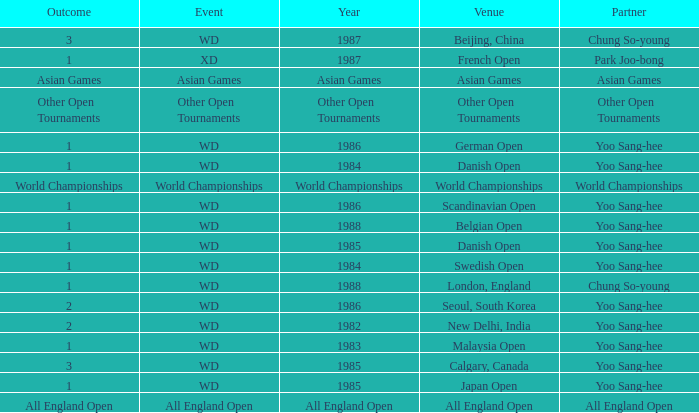What was the Outcome of the Danish Open in 1985? 1.0. 